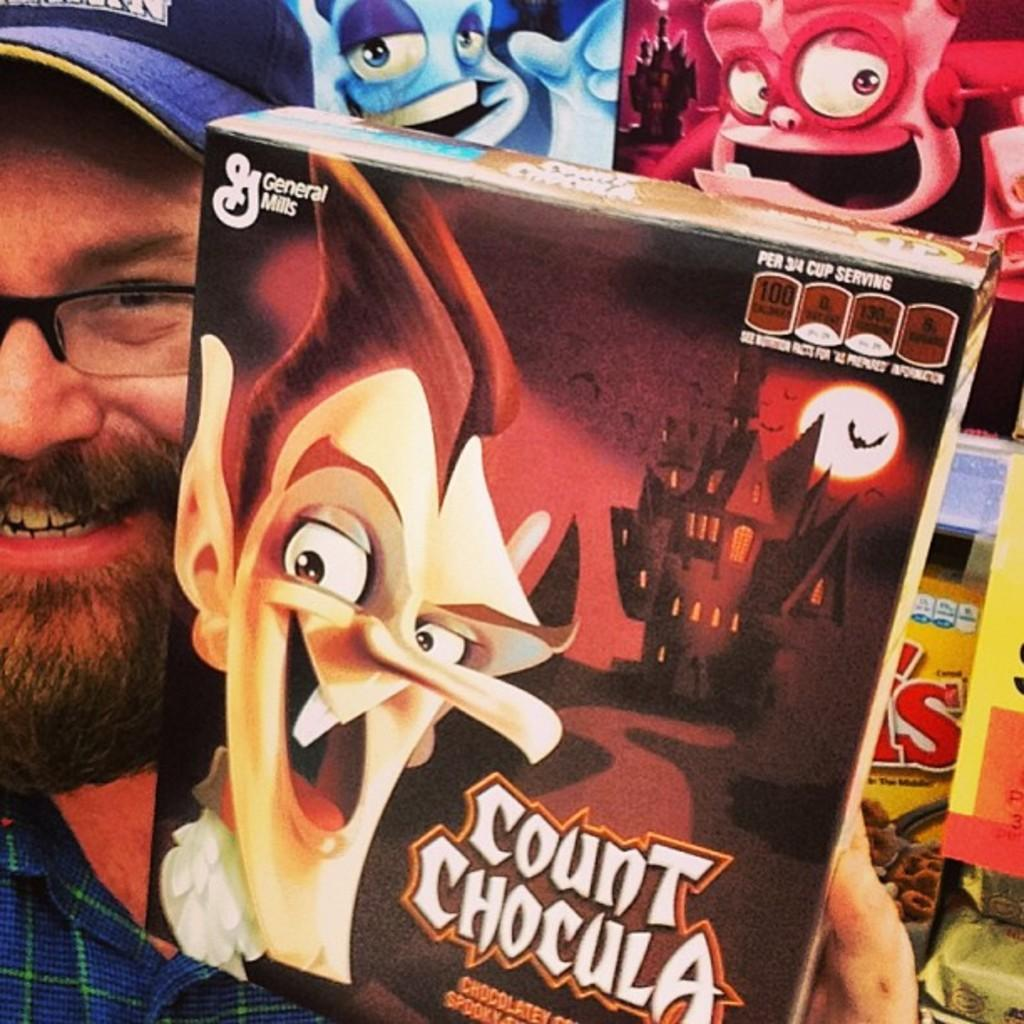Who is present in the image? There is a person in the image. What can be seen on the person's head? The person is wearing a cap. What facial feature is visible on the person? The person has a beard. What is the person holding in their hand? The person is holding an object in their hand. What else can be seen in the image besides the person? There are other objects visible behind the person. What type of prose is being recited by the person in the image? There is no indication in the image that the person is reciting any prose. 